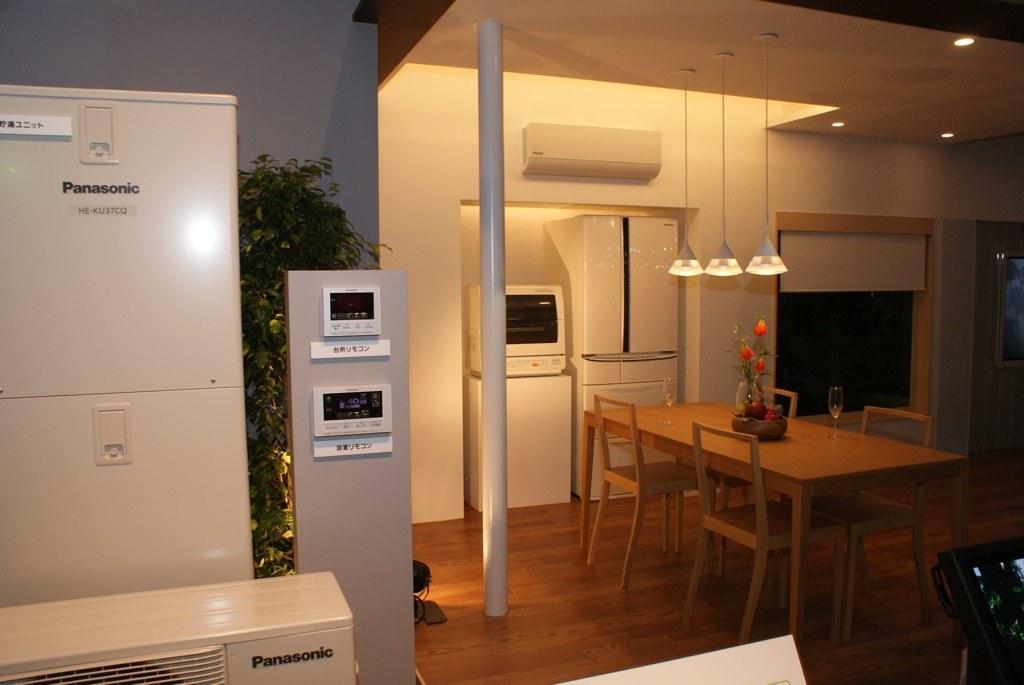Can you describe this image briefly? In this picture I can see refrigerators, chairs, table, wine glasses, house plant, lights and some other objects. 